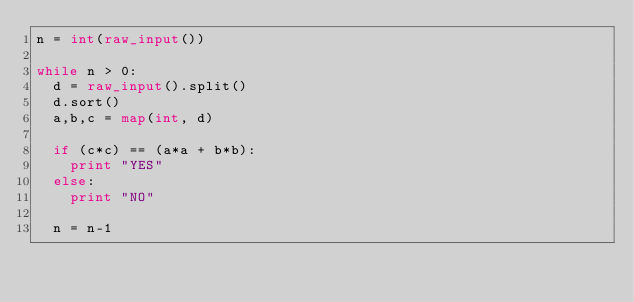Convert code to text. <code><loc_0><loc_0><loc_500><loc_500><_Python_>n = int(raw_input())

while n > 0:
  d = raw_input().split()
  d.sort()
  a,b,c = map(int, d)

  if (c*c) == (a*a + b*b):
    print "YES"
  else:
    print "NO"

  n = n-1</code> 